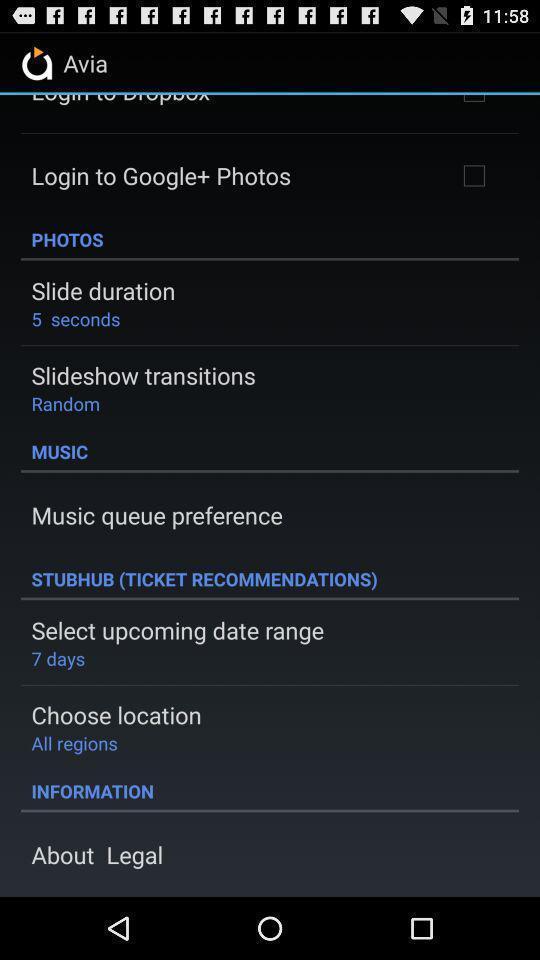Provide a detailed account of this screenshot. Various options in a music app. 